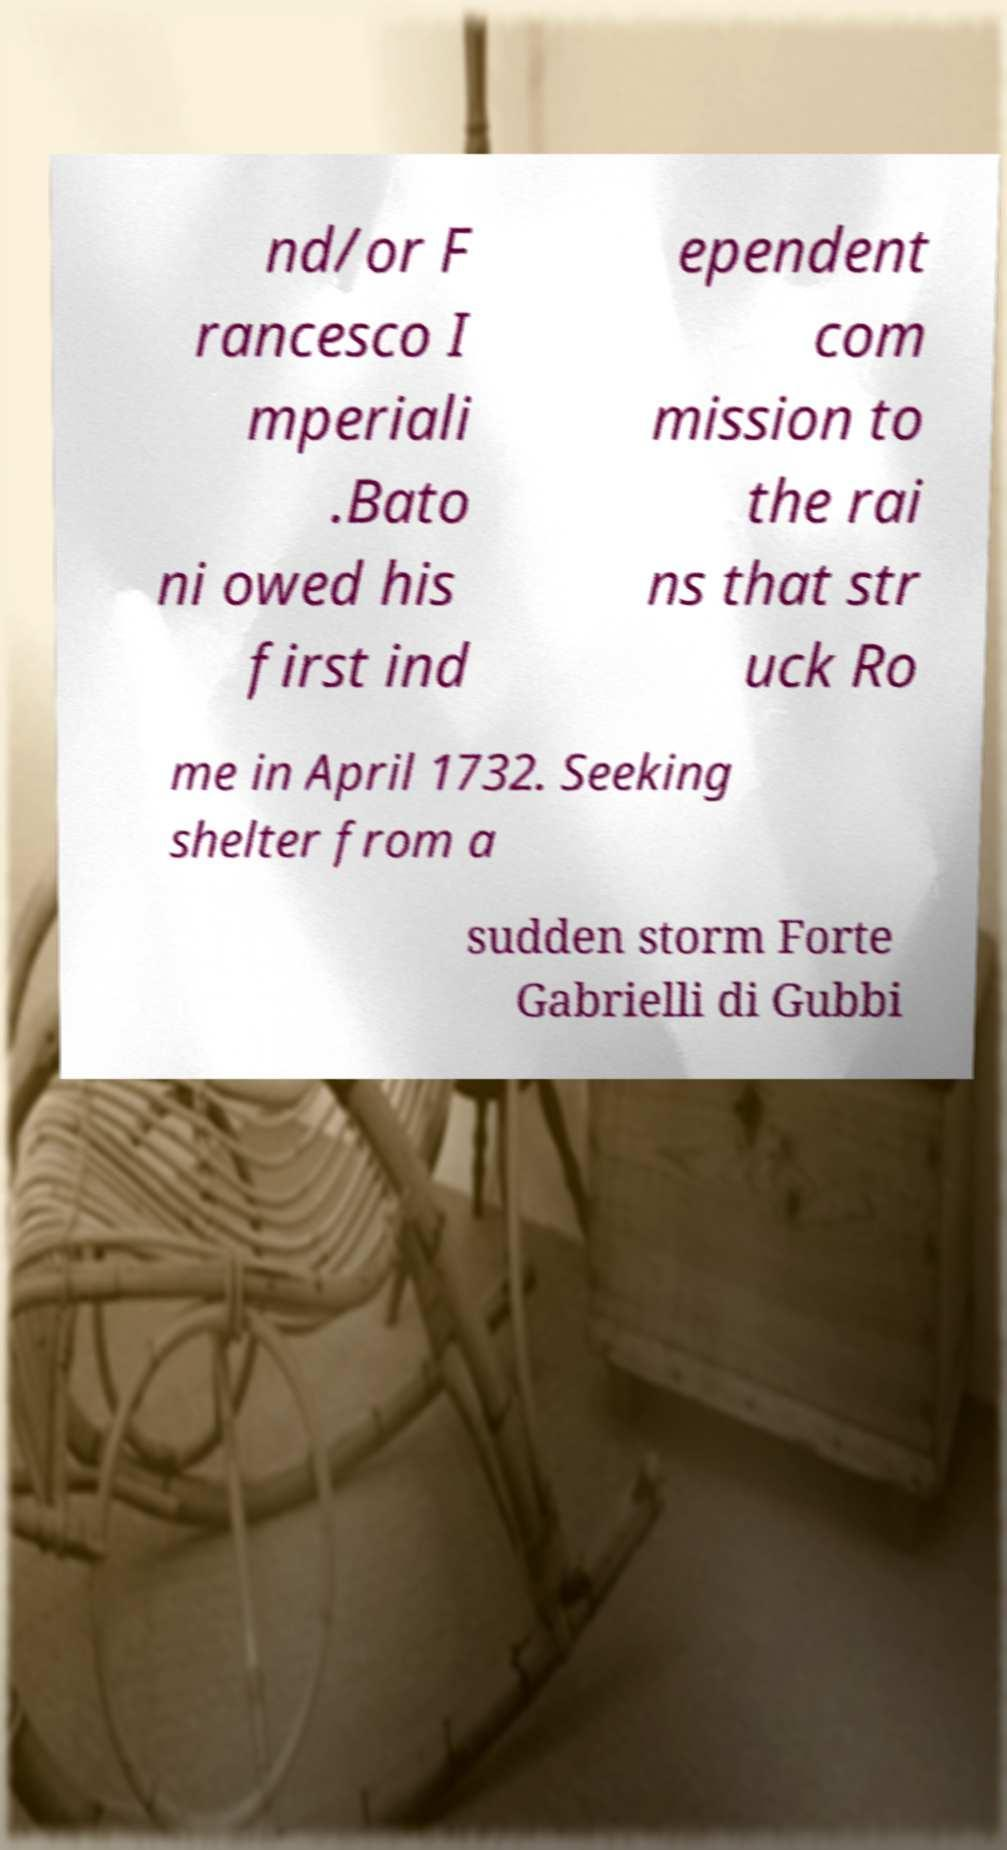For documentation purposes, I need the text within this image transcribed. Could you provide that? nd/or F rancesco I mperiali .Bato ni owed his first ind ependent com mission to the rai ns that str uck Ro me in April 1732. Seeking shelter from a sudden storm Forte Gabrielli di Gubbi 